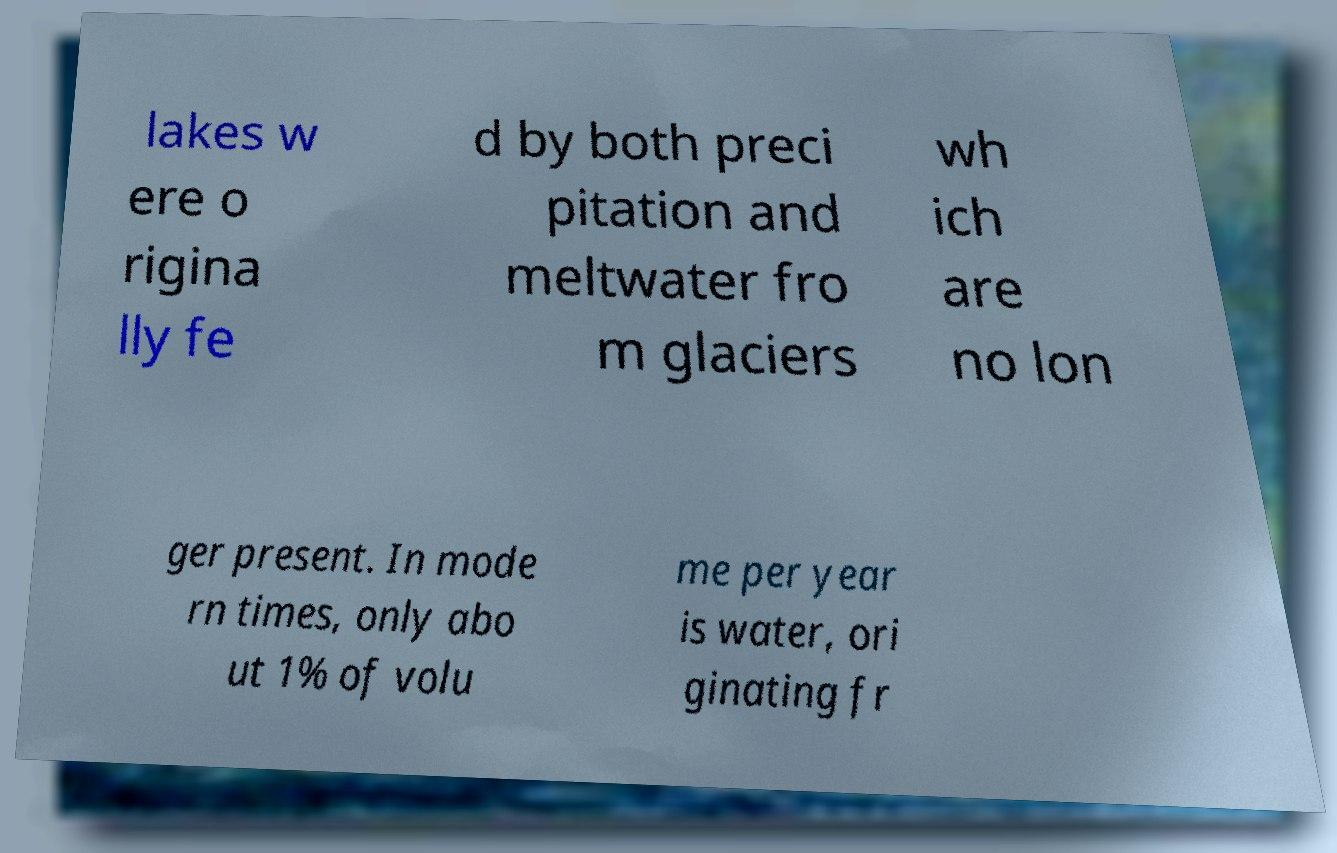Could you assist in decoding the text presented in this image and type it out clearly? lakes w ere o rigina lly fe d by both preci pitation and meltwater fro m glaciers wh ich are no lon ger present. In mode rn times, only abo ut 1% of volu me per year is water, ori ginating fr 